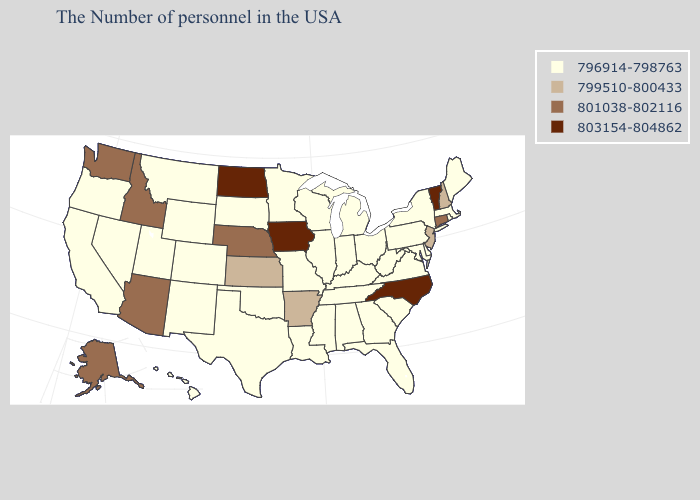Name the states that have a value in the range 801038-802116?
Quick response, please. Connecticut, Nebraska, Arizona, Idaho, Washington, Alaska. Does the first symbol in the legend represent the smallest category?
Be succinct. Yes. Name the states that have a value in the range 799510-800433?
Answer briefly. New Hampshire, New Jersey, Arkansas, Kansas. What is the value of North Dakota?
Give a very brief answer. 803154-804862. Name the states that have a value in the range 801038-802116?
Answer briefly. Connecticut, Nebraska, Arizona, Idaho, Washington, Alaska. Does Nevada have a lower value than Wyoming?
Give a very brief answer. No. What is the value of West Virginia?
Keep it brief. 796914-798763. Name the states that have a value in the range 799510-800433?
Be succinct. New Hampshire, New Jersey, Arkansas, Kansas. What is the lowest value in states that border Mississippi?
Keep it brief. 796914-798763. What is the value of Missouri?
Keep it brief. 796914-798763. Does North Dakota have the same value as Washington?
Keep it brief. No. Does North Carolina have the lowest value in the South?
Be succinct. No. What is the lowest value in states that border Indiana?
Quick response, please. 796914-798763. Name the states that have a value in the range 796914-798763?
Write a very short answer. Maine, Massachusetts, Rhode Island, New York, Delaware, Maryland, Pennsylvania, Virginia, South Carolina, West Virginia, Ohio, Florida, Georgia, Michigan, Kentucky, Indiana, Alabama, Tennessee, Wisconsin, Illinois, Mississippi, Louisiana, Missouri, Minnesota, Oklahoma, Texas, South Dakota, Wyoming, Colorado, New Mexico, Utah, Montana, Nevada, California, Oregon, Hawaii. 